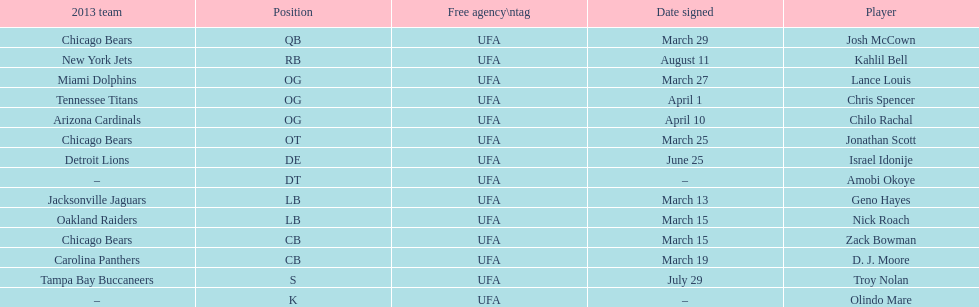In this chart, what is the most frequently played position? OG. 